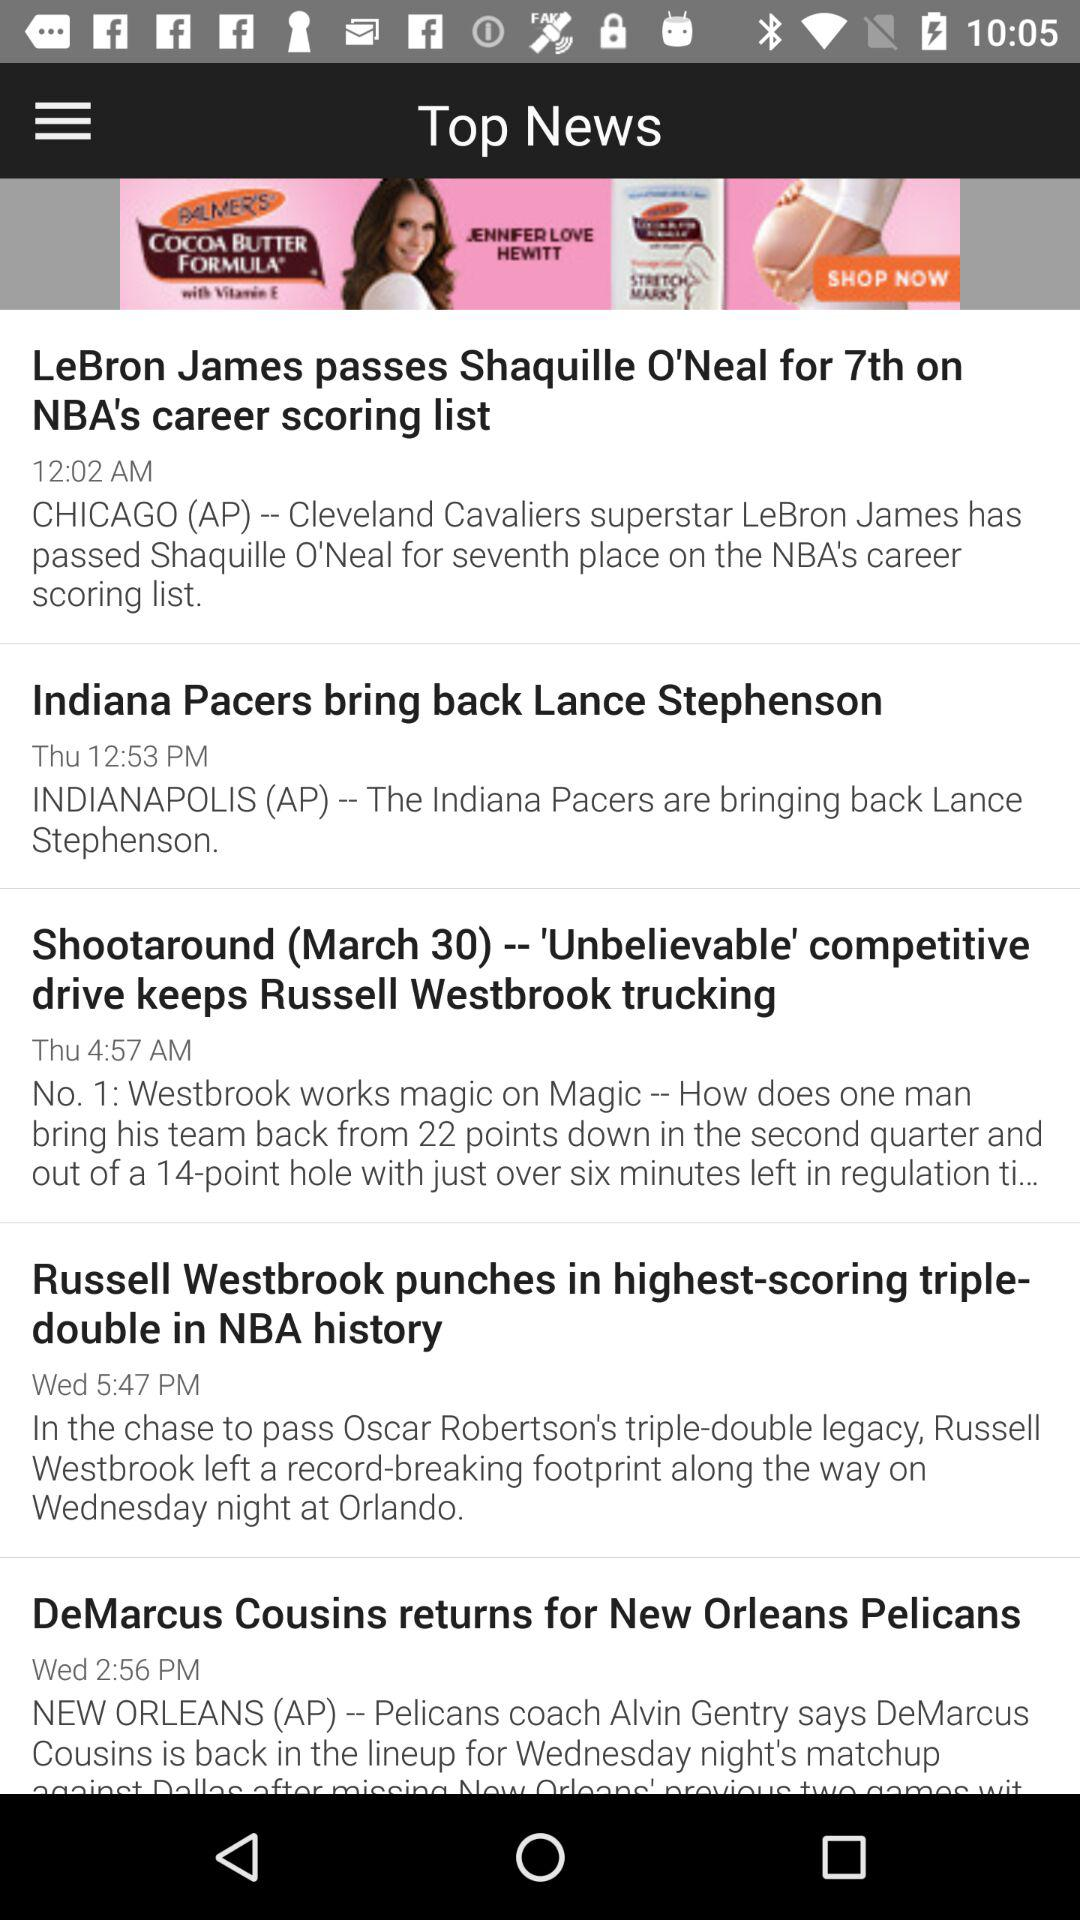What is the time of the news "Indiana Pacers bring back Lance Stephenson"? The time of the news is 12:53 PM. 